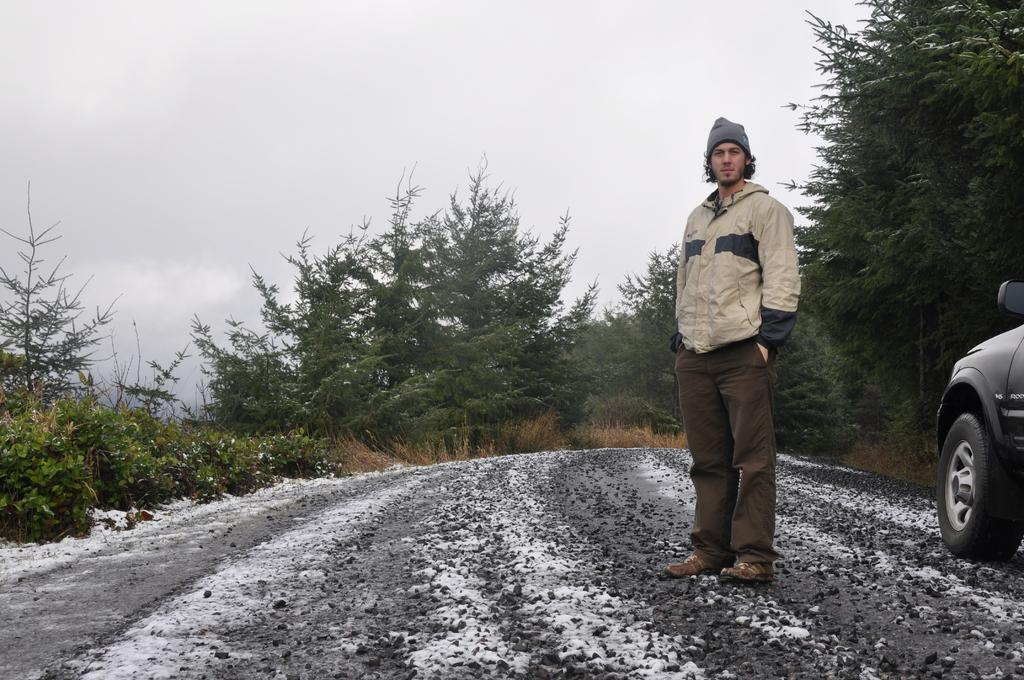What is the person in the image doing? The person is standing on the road. What else can be seen in the image? There is a vehicle in the right corner of the image. What surrounds the person on either side? There are plants and trees on either side of the person. How would you describe the sky in the image? The sky is cloudy. What type of border is visible between the person and the vehicle in the image? There is no border visible between the person and the vehicle in the image. 